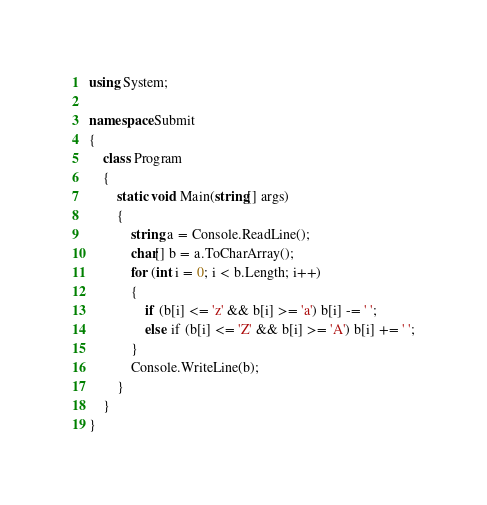<code> <loc_0><loc_0><loc_500><loc_500><_C#_>using System;

namespace Submit
{
    class Program
    {
        static void Main(string[] args)
        {
            string a = Console.ReadLine();
            char[] b = a.ToCharArray();
            for (int i = 0; i < b.Length; i++)
            {
                if (b[i] <= 'z' && b[i] >= 'a') b[i] -= ' ';
                else if (b[i] <= 'Z' && b[i] >= 'A') b[i] += ' ';
            }
            Console.WriteLine(b);
        }
    }
}
</code> 